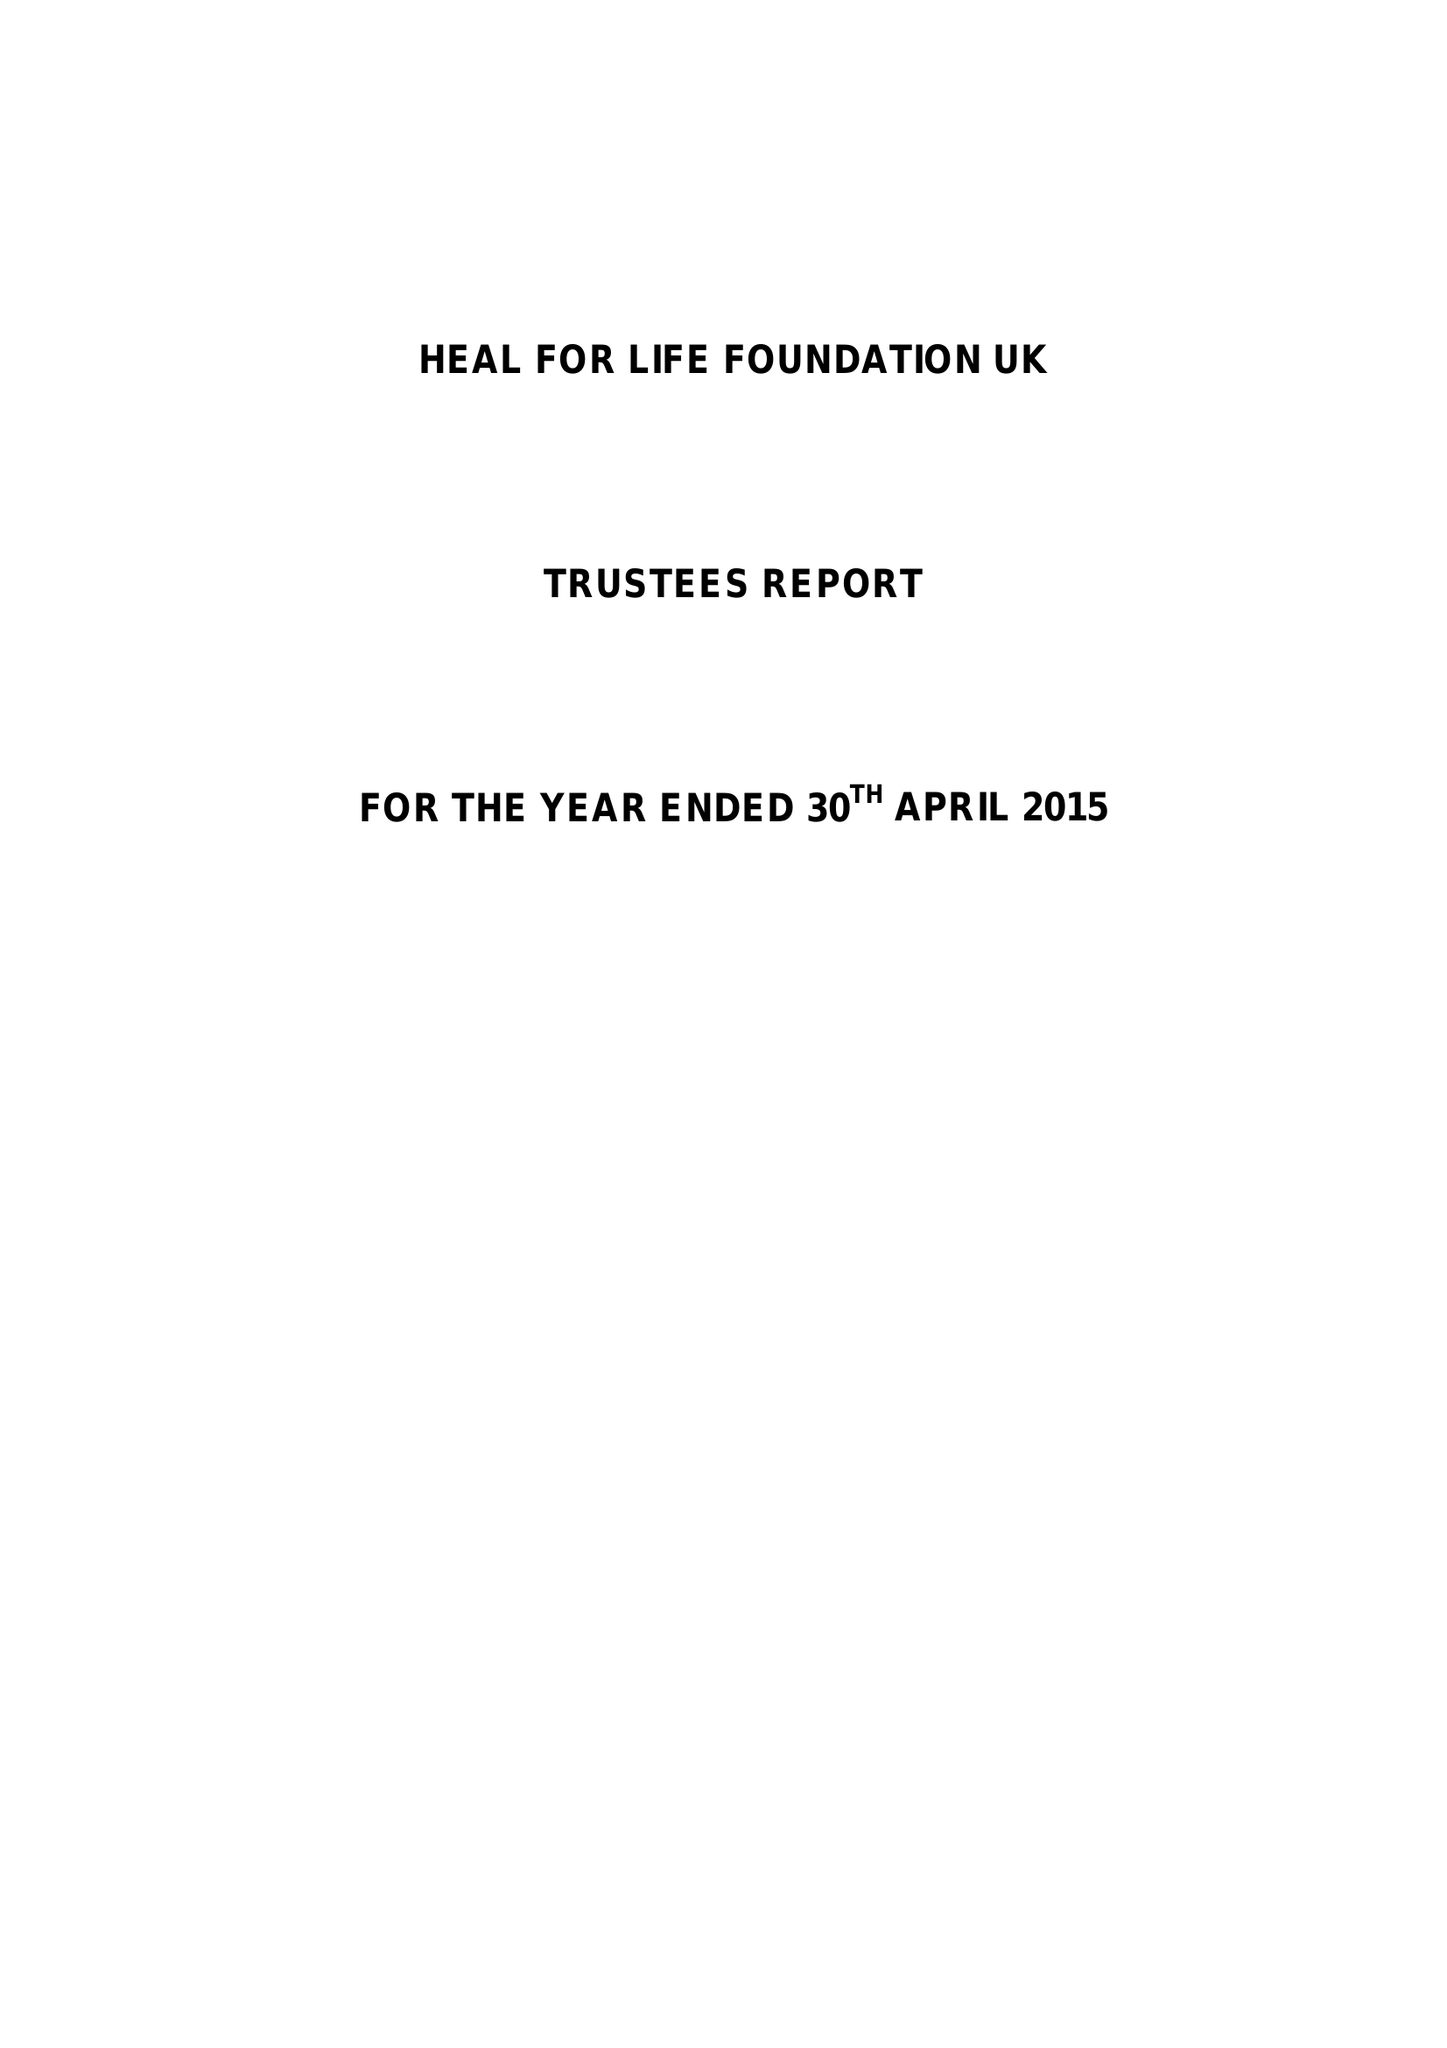What is the value for the address__post_town?
Answer the question using a single word or phrase. ASHFORD 